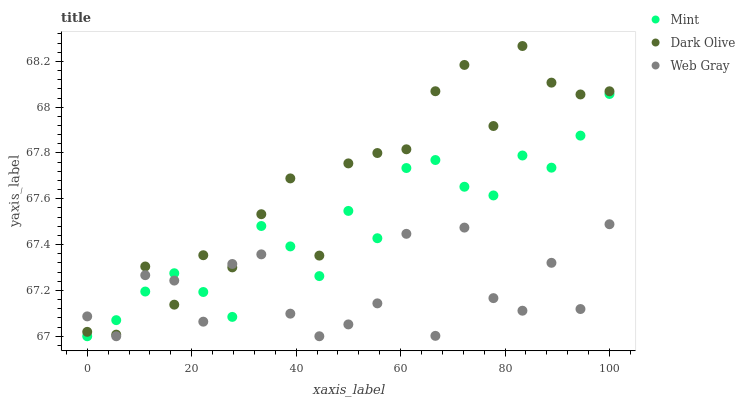Does Web Gray have the minimum area under the curve?
Answer yes or no. Yes. Does Dark Olive have the maximum area under the curve?
Answer yes or no. Yes. Does Mint have the minimum area under the curve?
Answer yes or no. No. Does Mint have the maximum area under the curve?
Answer yes or no. No. Is Mint the smoothest?
Answer yes or no. Yes. Is Web Gray the roughest?
Answer yes or no. Yes. Is Dark Olive the smoothest?
Answer yes or no. No. Is Dark Olive the roughest?
Answer yes or no. No. Does Web Gray have the lowest value?
Answer yes or no. Yes. Does Dark Olive have the lowest value?
Answer yes or no. No. Does Dark Olive have the highest value?
Answer yes or no. Yes. Does Mint have the highest value?
Answer yes or no. No. Does Dark Olive intersect Web Gray?
Answer yes or no. Yes. Is Dark Olive less than Web Gray?
Answer yes or no. No. Is Dark Olive greater than Web Gray?
Answer yes or no. No. 